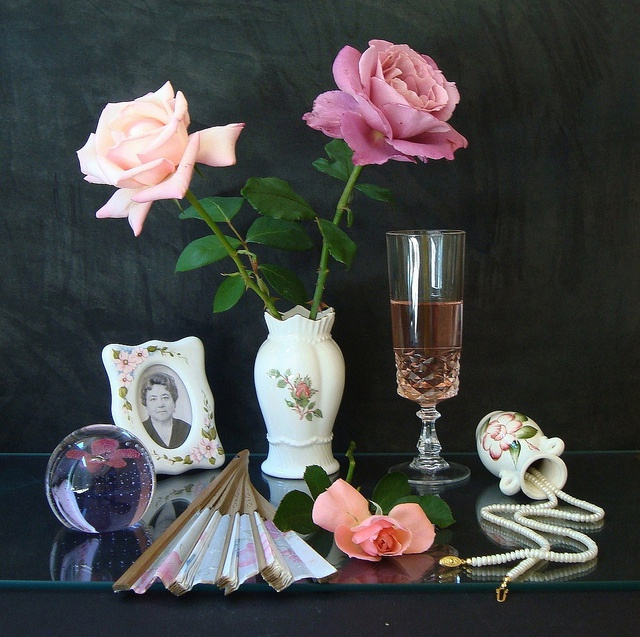Describe the objects in this image and their specific colors. I can see wine glass in black, gray, and maroon tones, vase in black, lightgray, and darkgray tones, vase in black, lightgray, darkgray, beige, and tan tones, and people in black, gray, darkgray, and lightgray tones in this image. 